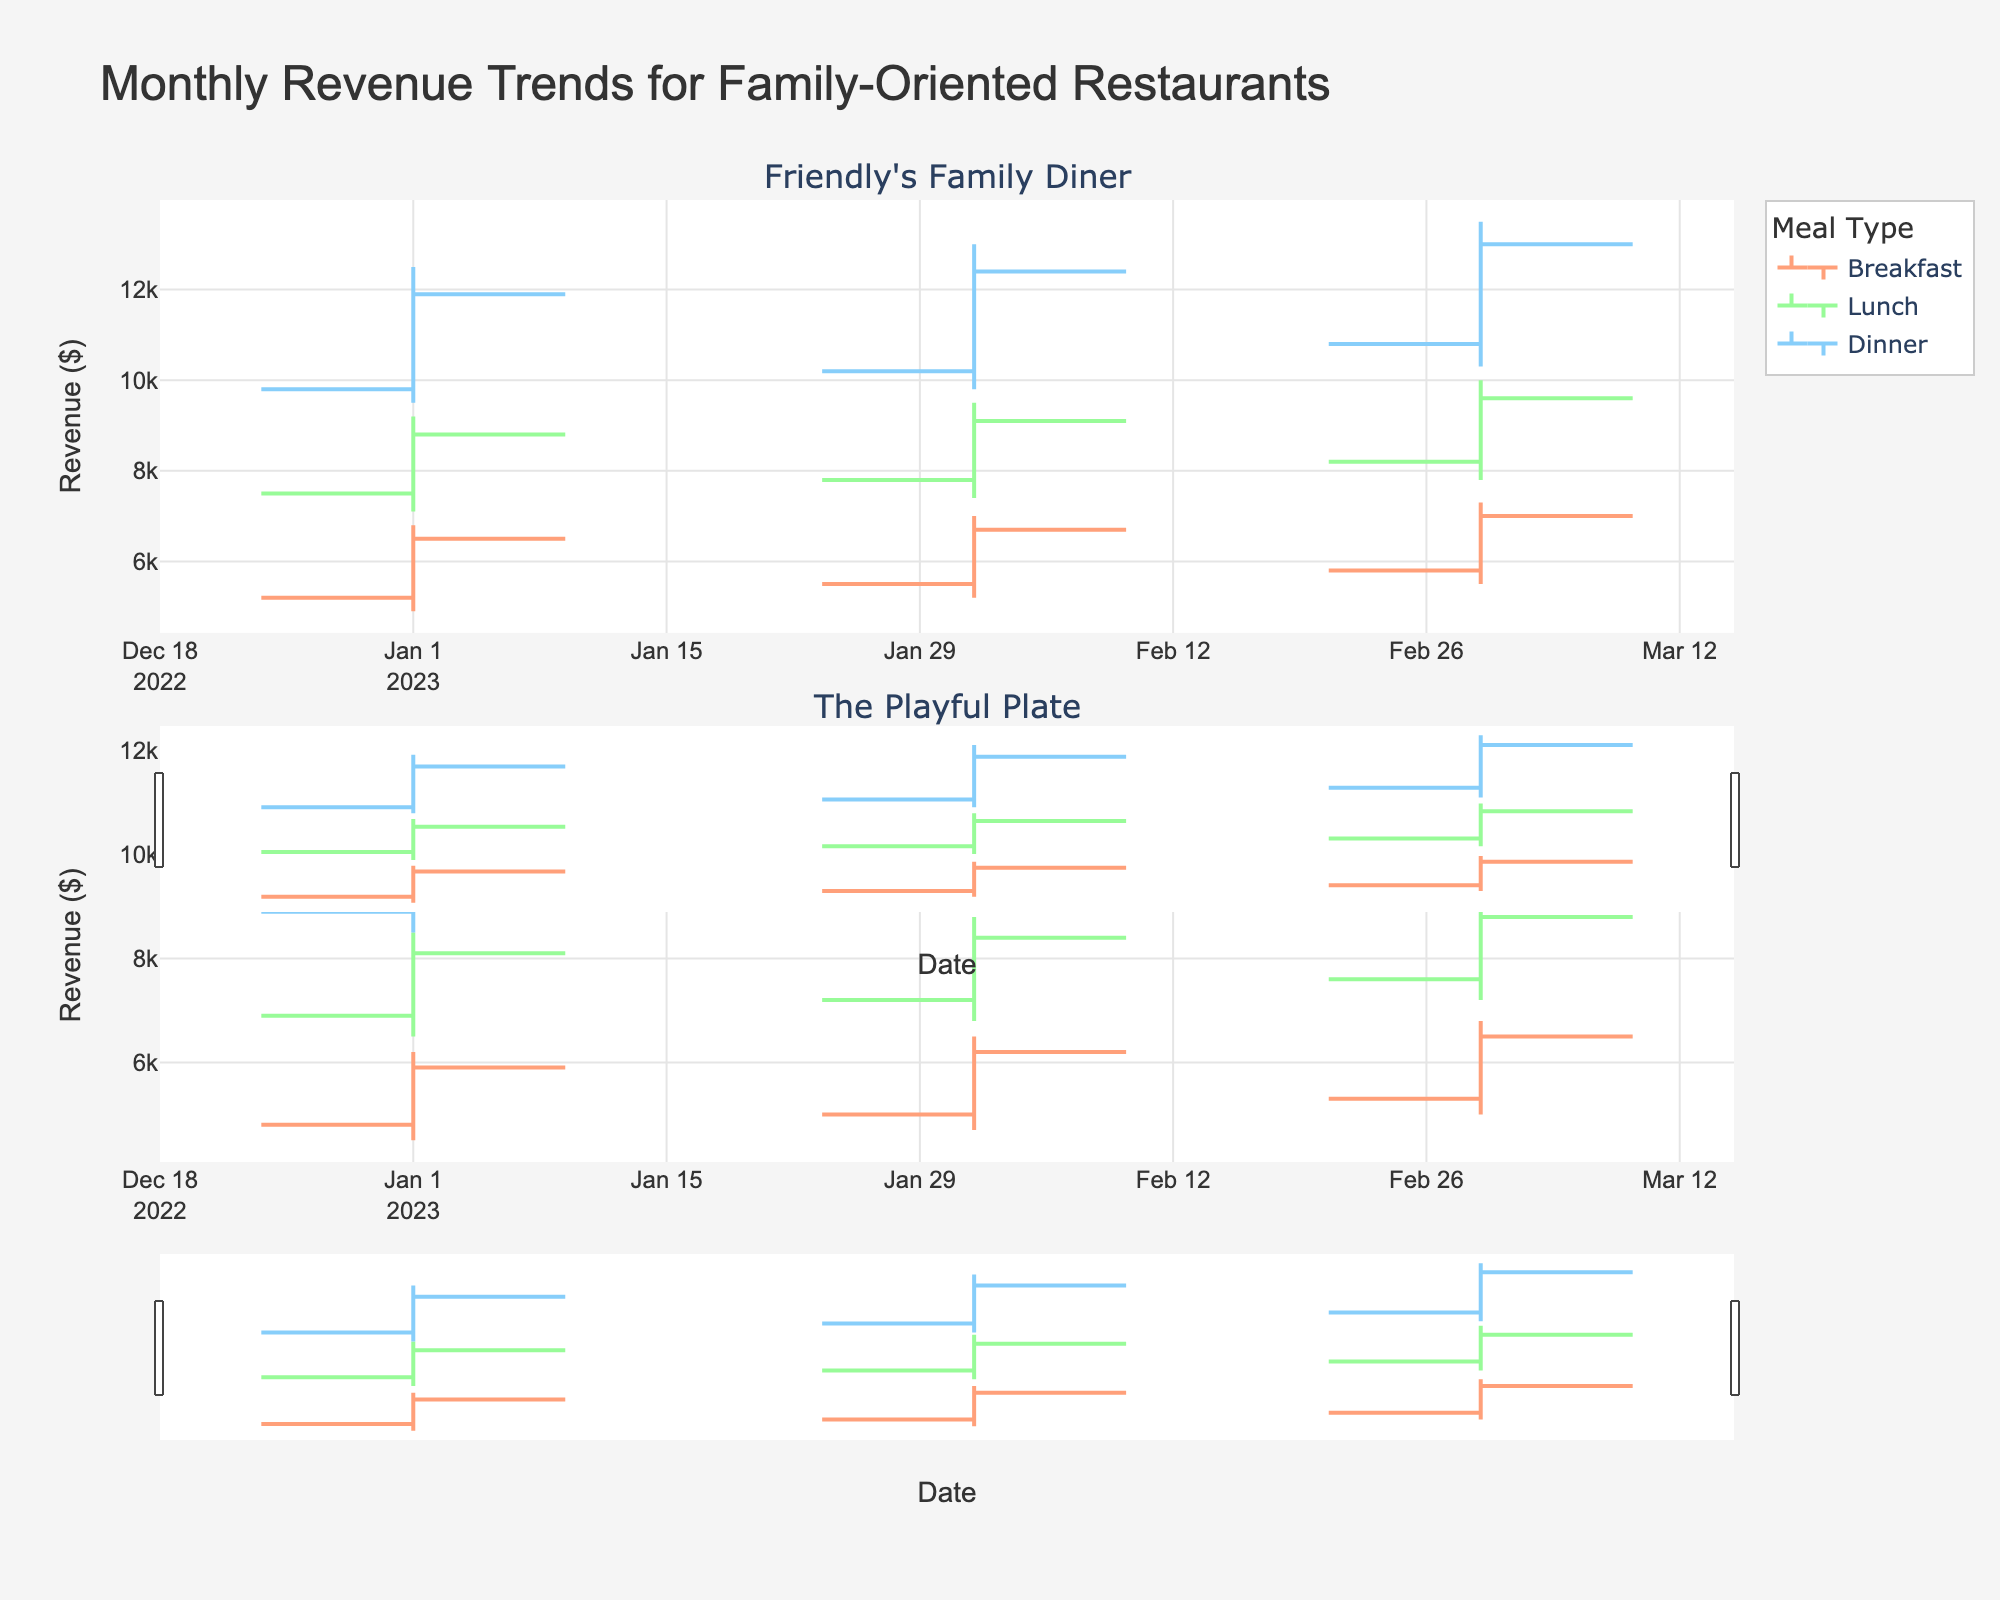What is the title of the figure? The title of the figure is displayed at the top of the plot. It reads "Monthly Revenue Trends for Family-Oriented Restaurants".
Answer: Monthly Revenue Trends for Family-Oriented Restaurants Which meal type has the highest revenue on January 1st, 2023 for Friendly's Family Diner? Look at the OHLC chart for January 1st, 2023, for Friendly's Family Diner. The dinner meal type shows the highest close value, which is $11,900.
Answer: Dinner What is the revenue range for lunch at The Playful Plate in February 2023? Look at the OHLC bar for lunch at The Playful Plate in February 2023. The high value is $8,800 and the low value is $6,800. Subtract the low from the high to find the range: $8800 - $6800 = $2000.
Answer: $2000 Which restaurant had a higher closing revenue for breakfast in March 2023? Compare the closing values of Friendly's Family Diner and The Playful Plate for breakfast in March 2023. Friendly's Family Diner had a close of $7000 and The Playful Plate had a close of $6500.
Answer: Friendly's Family Diner In which month did The Playful Plate have the lowest closing revenue for dinner? Check the OHLC charts for The Playful Plate across all months and find the closing values for dinner. January: $10500, February: $11000, March: $11600. The lowest closing revenue for dinner was in January with $10500.
Answer: January What was the opening revenue for lunch at Friendly's Family Diner in February 2023? Locate the OHLC bar for lunch at Friendly's Family Diner in February 2023 and check the opening value. It is listed as $7800.
Answer: $7800 What is the average closing revenue for breakfast at both restaurants in March 2023? Find the closing values for breakfast in March 2023 for both restaurants. Friendly's Family Diner: $7000, The Playful Plate: $6500. Average them: ($7000 + $6500) / 2 = $13500 / 2 = $6750.
Answer: $6750 Which meal type experienced the greatest fluctuation in revenue at Friendly's Family Diner in February 2023? For each meal type in February 2023 at Friendly's Family Diner, calculate the fluctuation by subtracting the low value from the high value. Breakfast: $7000 - $5200 = $1800, Lunch: $9500 - $7400 = $2100, Dinner: $13000 - $9800 = $3200. Dinner has the greatest fluctuation at $3200.
Answer: Dinner How did the closing revenue for lunch change at The Playful Plate from January to March 2023? Look at the closing values for lunch at The Playful Plate for January, February, and March 2023: January: $8100, February: $8400, March: $8800. Compare January to March: $8800 - $8100 = $700 increase.
Answer: Increased by $700 Which month had the highest overall revenue for Friendly's Family Diner? Add the closing values for all meal types at Friendly's Family Diner for each month. January: $6500 (Breakfast) + $8800 (Lunch) + $11900 (Dinner) = $27200. February: $6700 (Breakfast) + $9100 (Lunch) + $12400 (Dinner) = $28200. March: $7000 (Breakfast) + $9600 (Lunch) + $13000 (Dinner) = $29600. March had the highest overall revenue with $29600.
Answer: March 